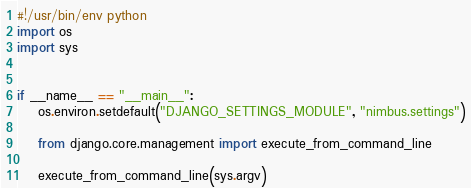<code> <loc_0><loc_0><loc_500><loc_500><_Python_>#!/usr/bin/env python
import os
import sys


if __name__ == "__main__":
    os.environ.setdefault("DJANGO_SETTINGS_MODULE", "nimbus.settings")

    from django.core.management import execute_from_command_line

    execute_from_command_line(sys.argv)
</code> 